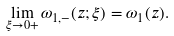Convert formula to latex. <formula><loc_0><loc_0><loc_500><loc_500>\lim _ { \xi \to 0 + } \omega _ { 1 , - } ( z ; \xi ) = \omega _ { 1 } ( z ) .</formula> 